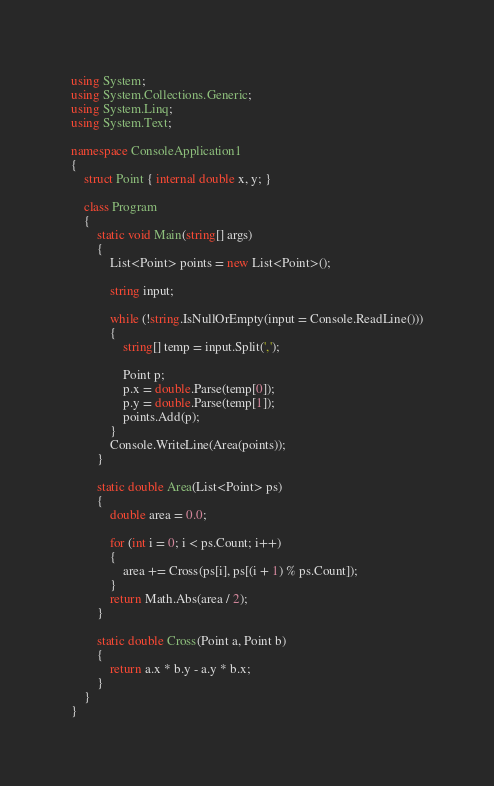Convert code to text. <code><loc_0><loc_0><loc_500><loc_500><_C#_>using System;
using System.Collections.Generic;
using System.Linq;
using System.Text;

namespace ConsoleApplication1
{
    struct Point { internal double x, y; }

    class Program
    {
        static void Main(string[] args)
        {
            List<Point> points = new List<Point>();

            string input;

            while (!string.IsNullOrEmpty(input = Console.ReadLine()))
            {
                string[] temp = input.Split(',');

                Point p;
                p.x = double.Parse(temp[0]);
                p.y = double.Parse(temp[1]);
                points.Add(p);
            }
            Console.WriteLine(Area(points));
        }

        static double Area(List<Point> ps)
        {
            double area = 0.0;

            for (int i = 0; i < ps.Count; i++)
            {
                area += Cross(ps[i], ps[(i + 1) % ps.Count]);
            }
            return Math.Abs(area / 2);
        }

        static double Cross(Point a, Point b)
        {
            return a.x * b.y - a.y * b.x;
        }
    }
}</code> 